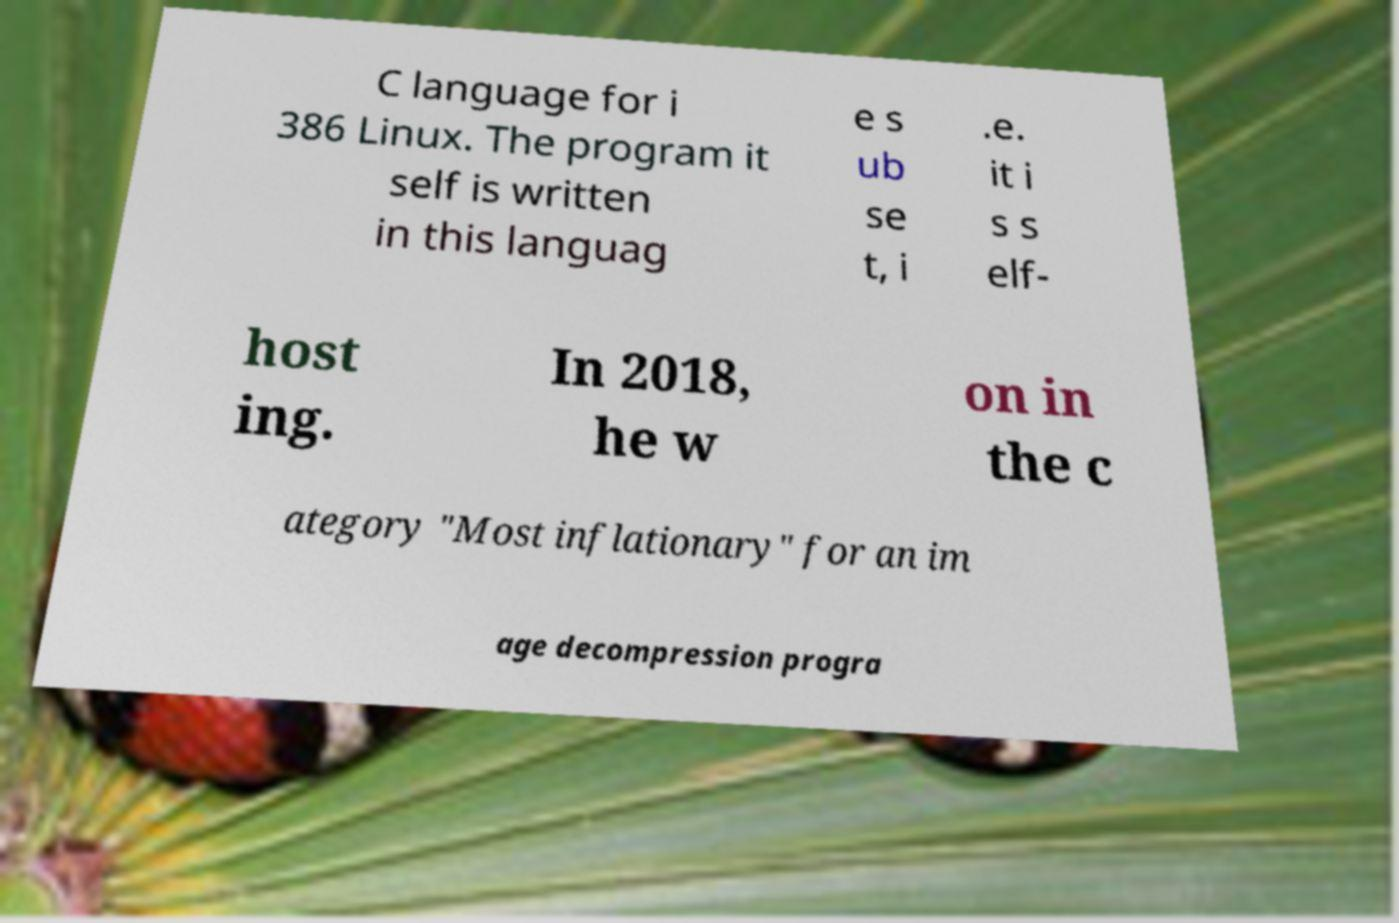What messages or text are displayed in this image? I need them in a readable, typed format. C language for i 386 Linux. The program it self is written in this languag e s ub se t, i .e. it i s s elf- host ing. In 2018, he w on in the c ategory "Most inflationary" for an im age decompression progra 